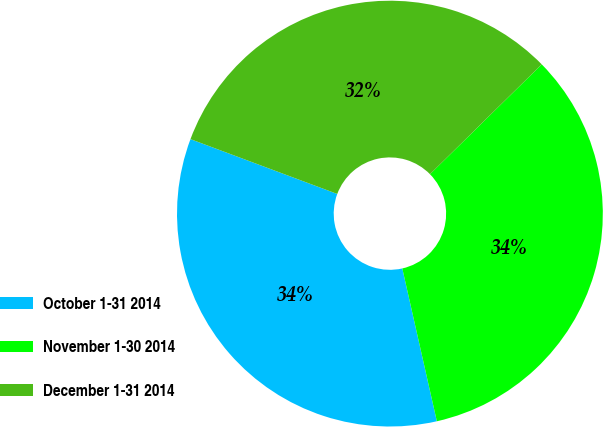Convert chart to OTSL. <chart><loc_0><loc_0><loc_500><loc_500><pie_chart><fcel>October 1-31 2014<fcel>November 1-30 2014<fcel>December 1-31 2014<nl><fcel>34.23%<fcel>33.83%<fcel>31.95%<nl></chart> 